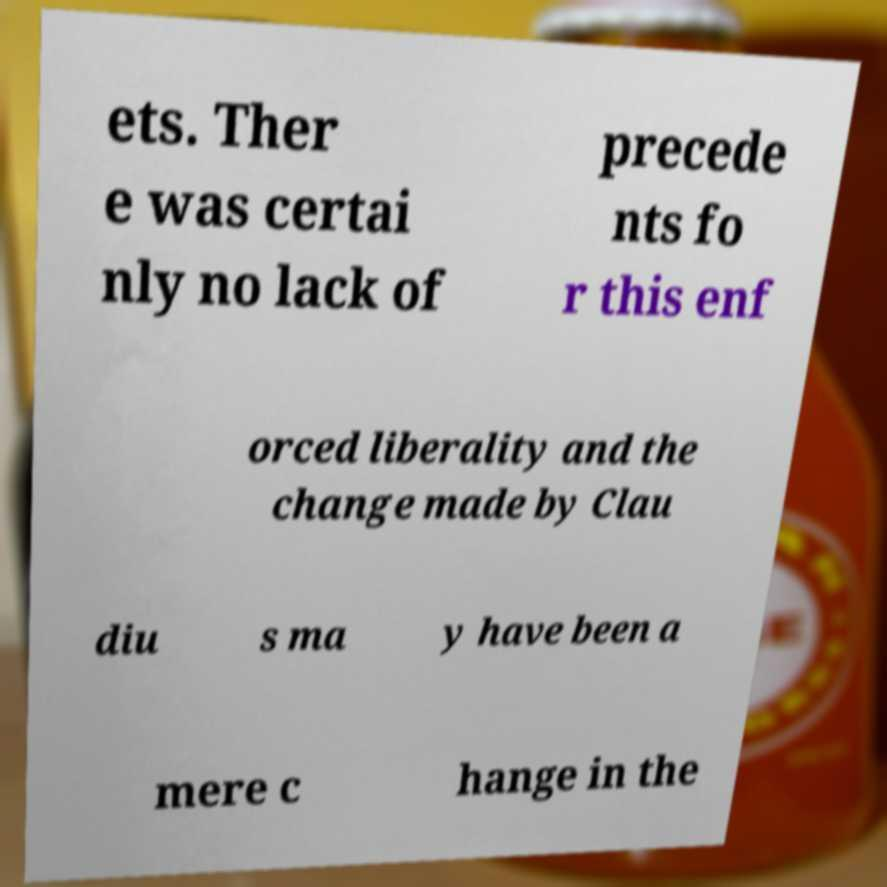I need the written content from this picture converted into text. Can you do that? ets. Ther e was certai nly no lack of precede nts fo r this enf orced liberality and the change made by Clau diu s ma y have been a mere c hange in the 